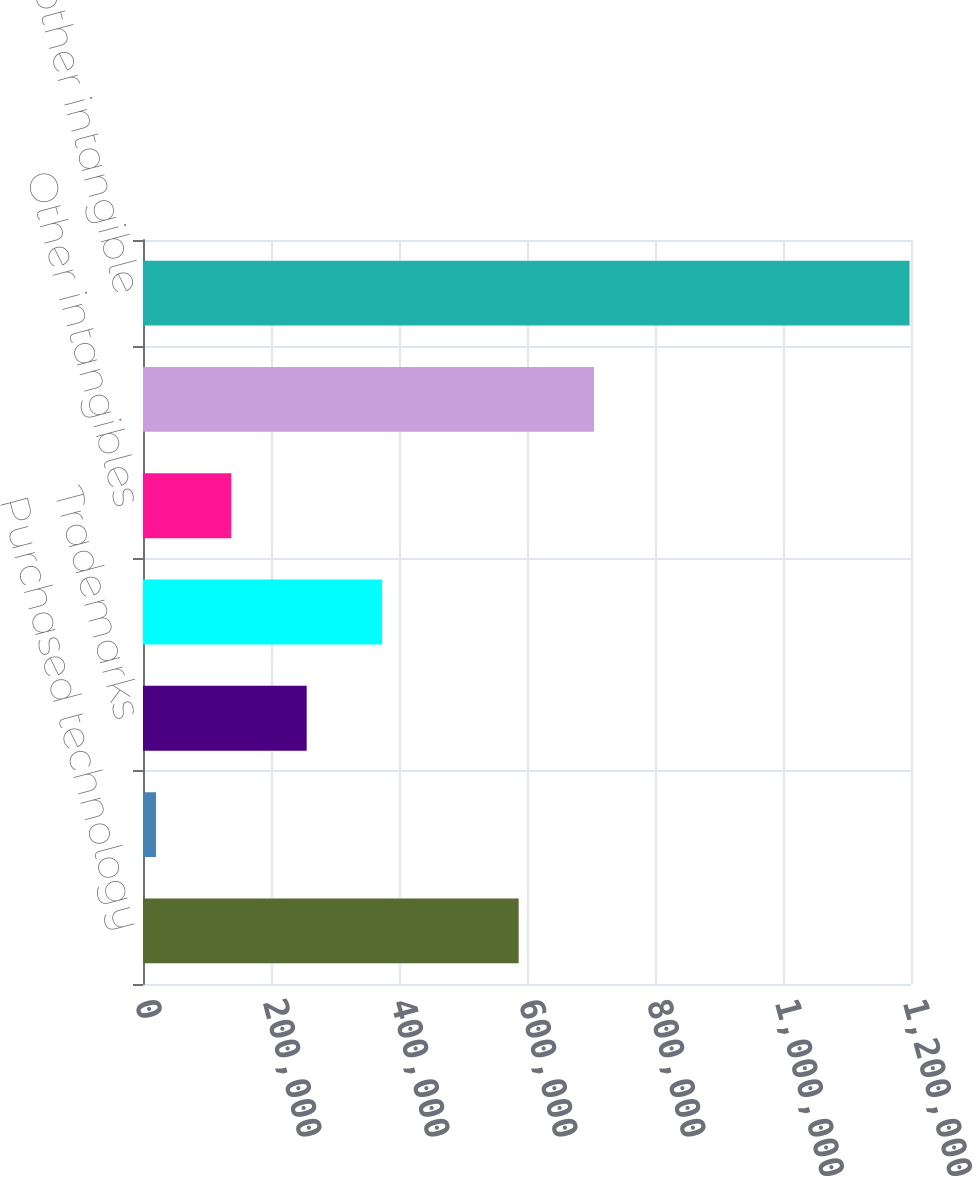Convert chart to OTSL. <chart><loc_0><loc_0><loc_500><loc_500><bar_chart><fcel>Purchased technology<fcel>Localization<fcel>Trademarks<fcel>Customer contracts and<fcel>Other intangibles<fcel>Total other intangible assets<fcel>Purchased and other intangible<nl><fcel>586952<fcel>20284<fcel>255772<fcel>373516<fcel>138028<fcel>704696<fcel>1.19772e+06<nl></chart> 